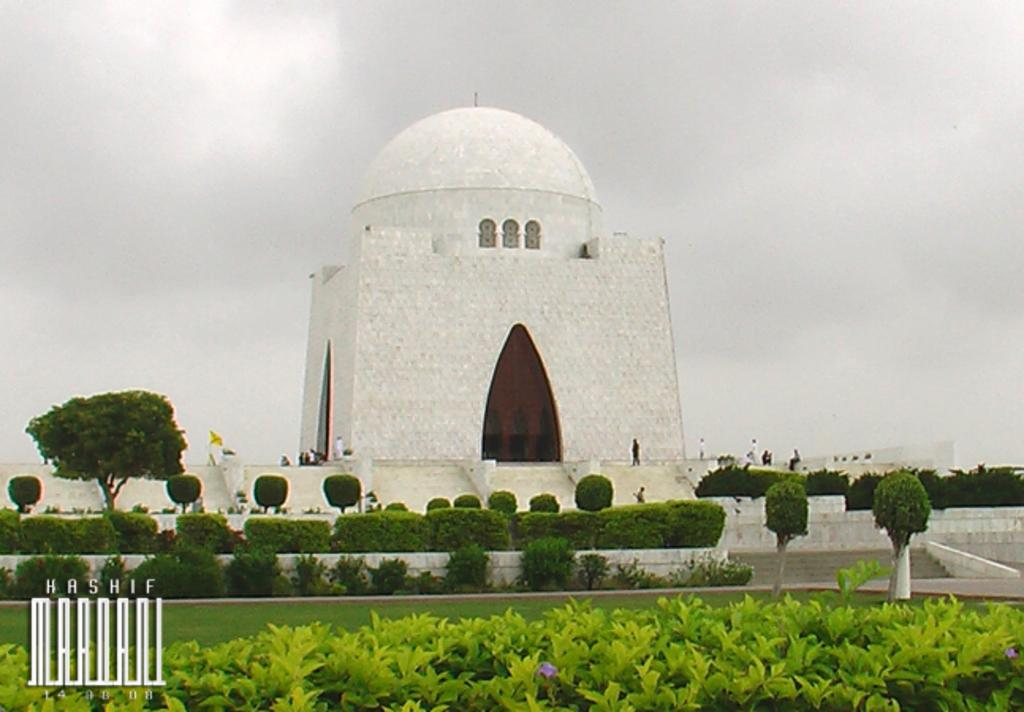What type of structure is present in the image? There is a building in the image. What is located in the middle of the image? There are persons in the middle of the image. What type of vegetation is on the left side of the image? There is a tree on the left side of the image. What type of plants are at the bottom of the image? There are bushes at the bottom of the image. What is visible at the top of the image? The sky is visible at the top of the image. What type of error can be seen on the paper in the image? There is no paper present in the image, so it is not possible to determine if there is an error on it. 